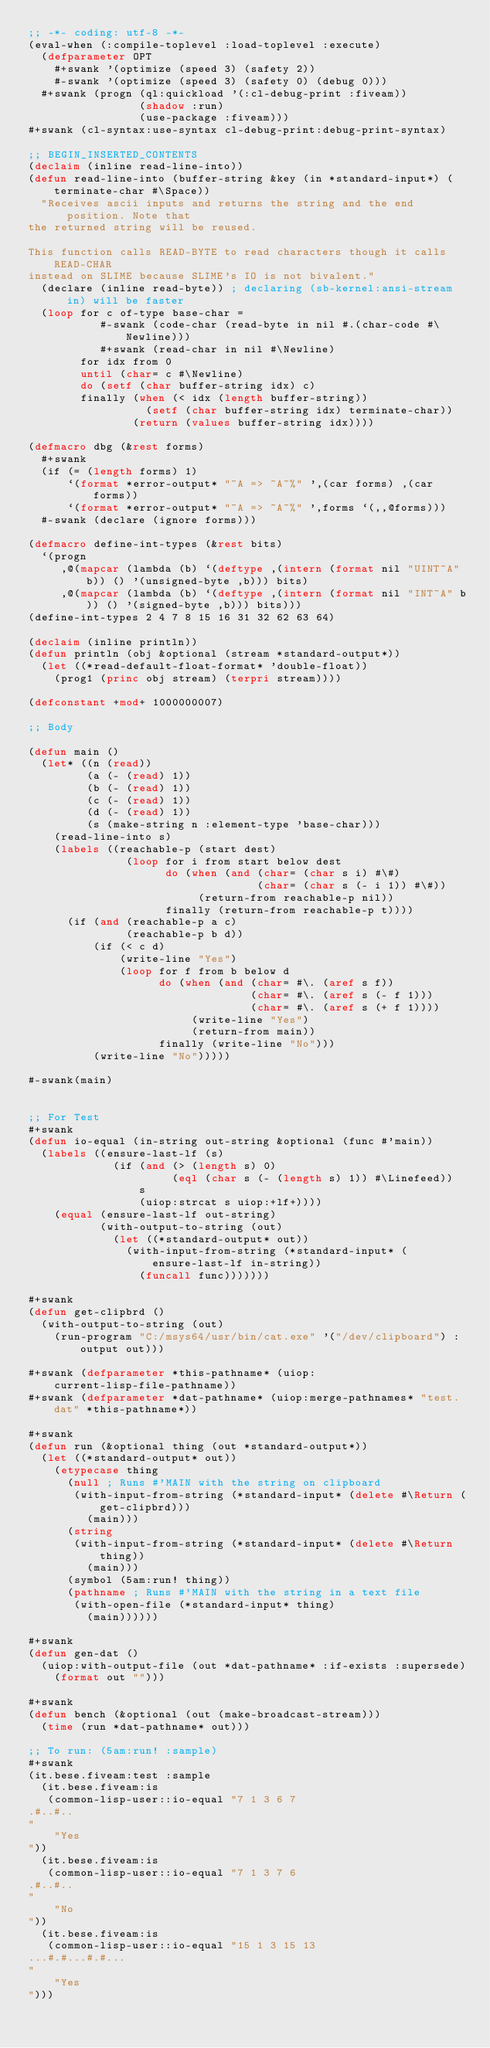<code> <loc_0><loc_0><loc_500><loc_500><_Lisp_>;; -*- coding: utf-8 -*-
(eval-when (:compile-toplevel :load-toplevel :execute)
  (defparameter OPT
    #+swank '(optimize (speed 3) (safety 2))
    #-swank '(optimize (speed 3) (safety 0) (debug 0)))
  #+swank (progn (ql:quickload '(:cl-debug-print :fiveam))
                 (shadow :run)
                 (use-package :fiveam)))
#+swank (cl-syntax:use-syntax cl-debug-print:debug-print-syntax)

;; BEGIN_INSERTED_CONTENTS
(declaim (inline read-line-into))
(defun read-line-into (buffer-string &key (in *standard-input*) (terminate-char #\Space))
  "Receives ascii inputs and returns the string and the end position. Note that
the returned string will be reused.

This function calls READ-BYTE to read characters though it calls READ-CHAR
instead on SLIME because SLIME's IO is not bivalent."
  (declare (inline read-byte)) ; declaring (sb-kernel:ansi-stream in) will be faster
  (loop for c of-type base-char =
           #-swank (code-char (read-byte in nil #.(char-code #\Newline)))
           #+swank (read-char in nil #\Newline)
        for idx from 0
        until (char= c #\Newline)
        do (setf (char buffer-string idx) c)
        finally (when (< idx (length buffer-string))
                  (setf (char buffer-string idx) terminate-char))
                (return (values buffer-string idx))))

(defmacro dbg (&rest forms)
  #+swank
  (if (= (length forms) 1)
      `(format *error-output* "~A => ~A~%" ',(car forms) ,(car forms))
      `(format *error-output* "~A => ~A~%" ',forms `(,,@forms)))
  #-swank (declare (ignore forms)))

(defmacro define-int-types (&rest bits)
  `(progn
     ,@(mapcar (lambda (b) `(deftype ,(intern (format nil "UINT~A" b)) () '(unsigned-byte ,b))) bits)
     ,@(mapcar (lambda (b) `(deftype ,(intern (format nil "INT~A" b)) () '(signed-byte ,b))) bits)))
(define-int-types 2 4 7 8 15 16 31 32 62 63 64)

(declaim (inline println))
(defun println (obj &optional (stream *standard-output*))
  (let ((*read-default-float-format* 'double-float))
    (prog1 (princ obj stream) (terpri stream))))

(defconstant +mod+ 1000000007)

;; Body

(defun main ()
  (let* ((n (read))
         (a (- (read) 1))
         (b (- (read) 1))
         (c (- (read) 1))
         (d (- (read) 1))
         (s (make-string n :element-type 'base-char)))
    (read-line-into s)
    (labels ((reachable-p (start dest)
               (loop for i from start below dest
                     do (when (and (char= (char s i) #\#)
                                   (char= (char s (- i 1)) #\#))
                          (return-from reachable-p nil))
                     finally (return-from reachable-p t))))
      (if (and (reachable-p a c)
               (reachable-p b d))
          (if (< c d)
              (write-line "Yes")
              (loop for f from b below d
                    do (when (and (char= #\. (aref s f))
                                  (char= #\. (aref s (- f 1)))
                                  (char= #\. (aref s (+ f 1))))
                         (write-line "Yes")
                         (return-from main))
                    finally (write-line "No")))
          (write-line "No")))))

#-swank(main)


;; For Test
#+swank
(defun io-equal (in-string out-string &optional (func #'main))
  (labels ((ensure-last-lf (s)
             (if (and (> (length s) 0)
                      (eql (char s (- (length s) 1)) #\Linefeed))
                 s
                 (uiop:strcat s uiop:+lf+))))
    (equal (ensure-last-lf out-string)
           (with-output-to-string (out)
             (let ((*standard-output* out))
               (with-input-from-string (*standard-input* (ensure-last-lf in-string))
                 (funcall func)))))))

#+swank
(defun get-clipbrd ()
  (with-output-to-string (out)
    (run-program "C:/msys64/usr/bin/cat.exe" '("/dev/clipboard") :output out)))

#+swank (defparameter *this-pathname* (uiop:current-lisp-file-pathname))
#+swank (defparameter *dat-pathname* (uiop:merge-pathnames* "test.dat" *this-pathname*))

#+swank
(defun run (&optional thing (out *standard-output*))
  (let ((*standard-output* out))
    (etypecase thing
      (null ; Runs #'MAIN with the string on clipboard
       (with-input-from-string (*standard-input* (delete #\Return (get-clipbrd)))
         (main)))
      (string
       (with-input-from-string (*standard-input* (delete #\Return thing))
         (main)))
      (symbol (5am:run! thing))
      (pathname ; Runs #'MAIN with the string in a text file
       (with-open-file (*standard-input* thing)
         (main))))))

#+swank
(defun gen-dat ()
  (uiop:with-output-file (out *dat-pathname* :if-exists :supersede)
    (format out "")))

#+swank
(defun bench (&optional (out (make-broadcast-stream)))
  (time (run *dat-pathname* out)))

;; To run: (5am:run! :sample)
#+swank
(it.bese.fiveam:test :sample
  (it.bese.fiveam:is
   (common-lisp-user::io-equal "7 1 3 6 7
.#..#..
"
    "Yes
"))
  (it.bese.fiveam:is
   (common-lisp-user::io-equal "7 1 3 7 6
.#..#..
"
    "No
"))
  (it.bese.fiveam:is
   (common-lisp-user::io-equal "15 1 3 15 13
...#.#...#.#...
"
    "Yes
")))
</code> 